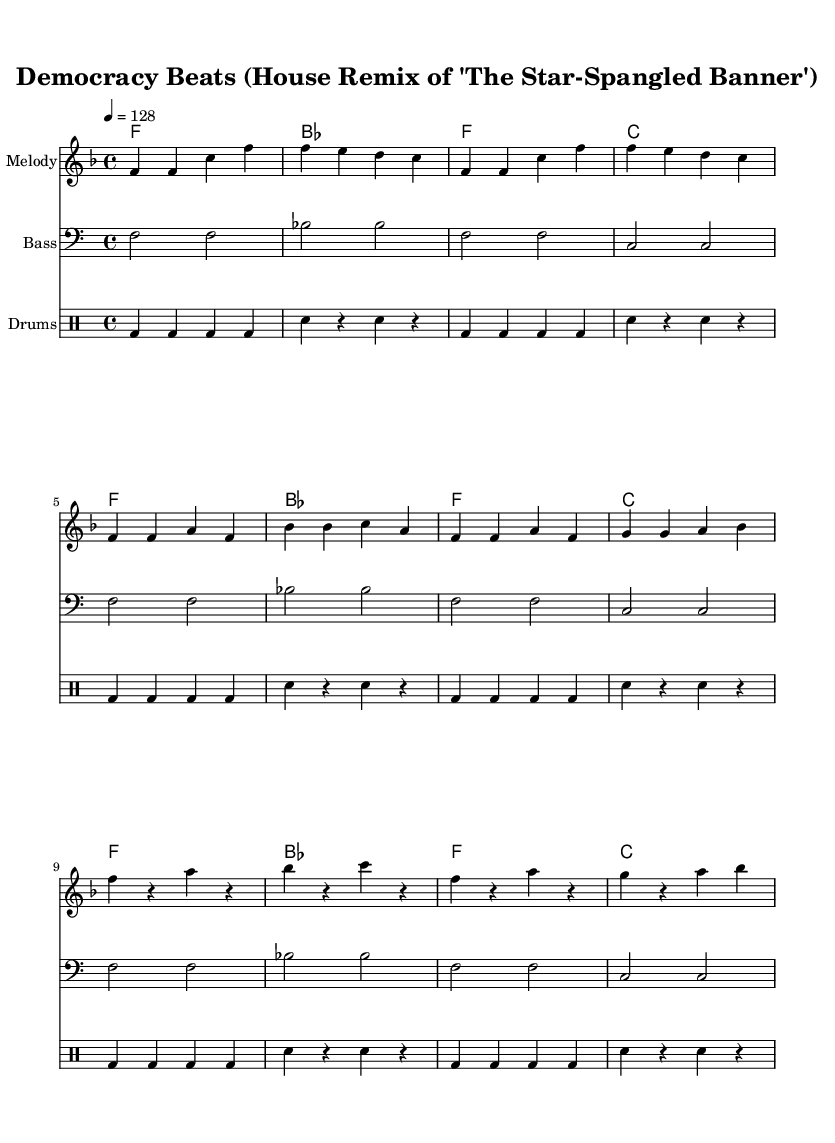What is the key signature of this music? The key signature is F major, which has one flat (B flat). We can determine the key signature by looking at the global settings in the score, where 'f' is indicated as the key.
Answer: F major What is the time signature of this music? The time signature is 4/4, which indicates that there are four beats per measure, and each quarter note receives one beat. This can be verified from the global settings where the time signature is specified.
Answer: 4/4 What is the tempo marking of this piece? The tempo marking is 128 BPM (beats per minute), indicated by “\tempo 4 = 128” in the score. This specifies the speed at which the piece should be played.
Answer: 128 How many measures are in the melody section? The melody section contains a total of 8 measures. By counting the measures in the melody part from the provided music code, we can determine this number.
Answer: 8 What type of rhythm is primarily used in the drum section? The drum section primarily uses a steady kick-snare rhythm pattern typical of house music. This can be seen through the repetition of kick (bd) and snare (sn) hits throughout the drum part.
Answer: Kick-snare What musical form does this remix primarily follow? The music follows a verse-drop structure typical in house remixes, where it alternates between the verse and a more energetic drop section. This can be deduced by identifying the melodic and rhythmic contrasts between the verse and the drop in the score.
Answer: Verse-drop What is the bass's clef in this music? The bass's clef in this music is bass clef, indicated directly by "clef bass" in the score. This is essential for understanding how low notes are represented in this part.
Answer: Bass clef 